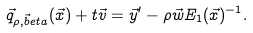Convert formula to latex. <formula><loc_0><loc_0><loc_500><loc_500>\vec { q } _ { \rho , \vec { b } e t a } ( \vec { x } ) + t \vec { v } = \vec { y } ^ { \prime } - \rho \vec { w } E _ { 1 } ( \vec { x } ) ^ { - 1 } .</formula> 